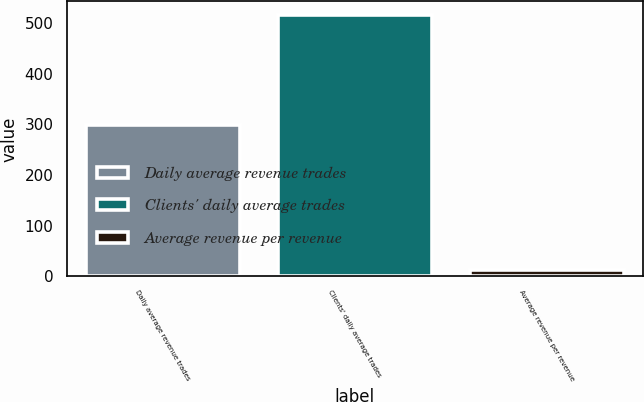Convert chart to OTSL. <chart><loc_0><loc_0><loc_500><loc_500><bar_chart><fcel>Daily average revenue trades<fcel>Clients' daily average trades<fcel>Average revenue per revenue<nl><fcel>298.2<fcel>516.8<fcel>12.13<nl></chart> 